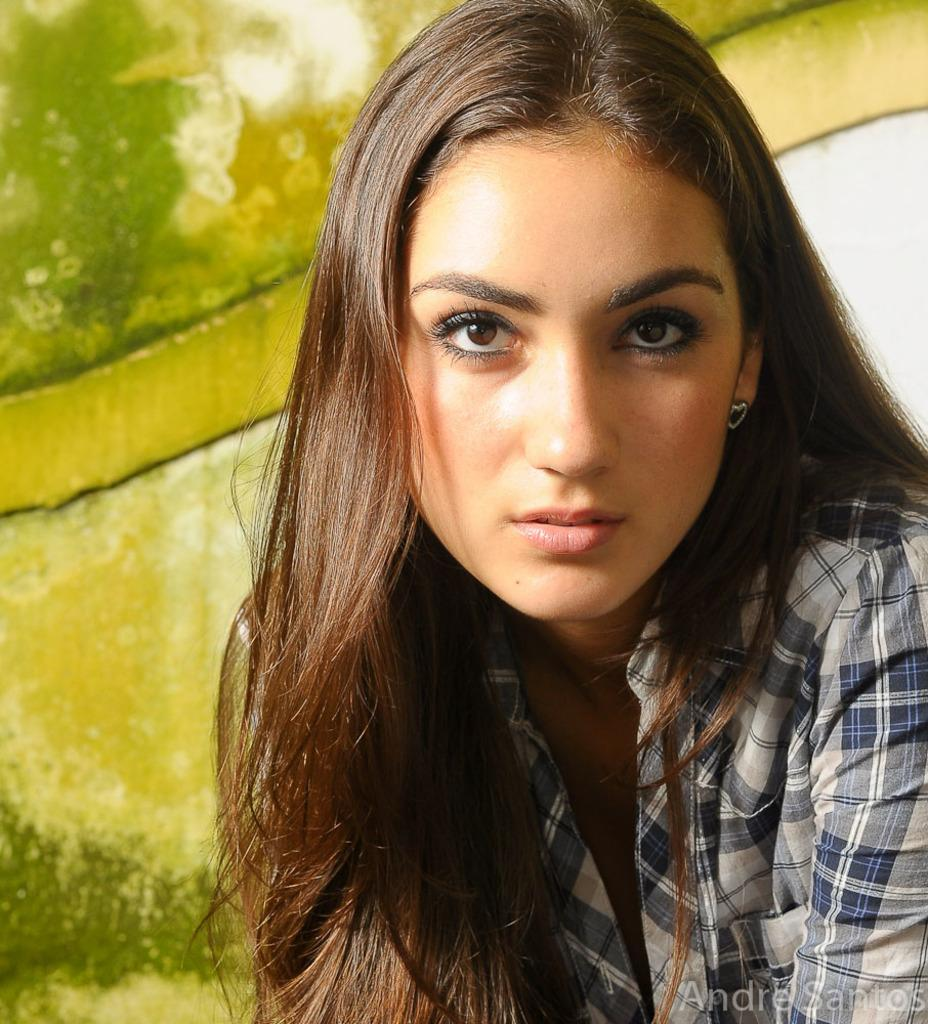What is the main subject of the image? There is a woman in the image. Can you describe any additional features or elements in the image? There is a watermark at the bottom of the image. What type of comfort does the goose provide for the scarecrow in the image? There is no goose or scarecrow present in the image; it features a woman and a watermark. 